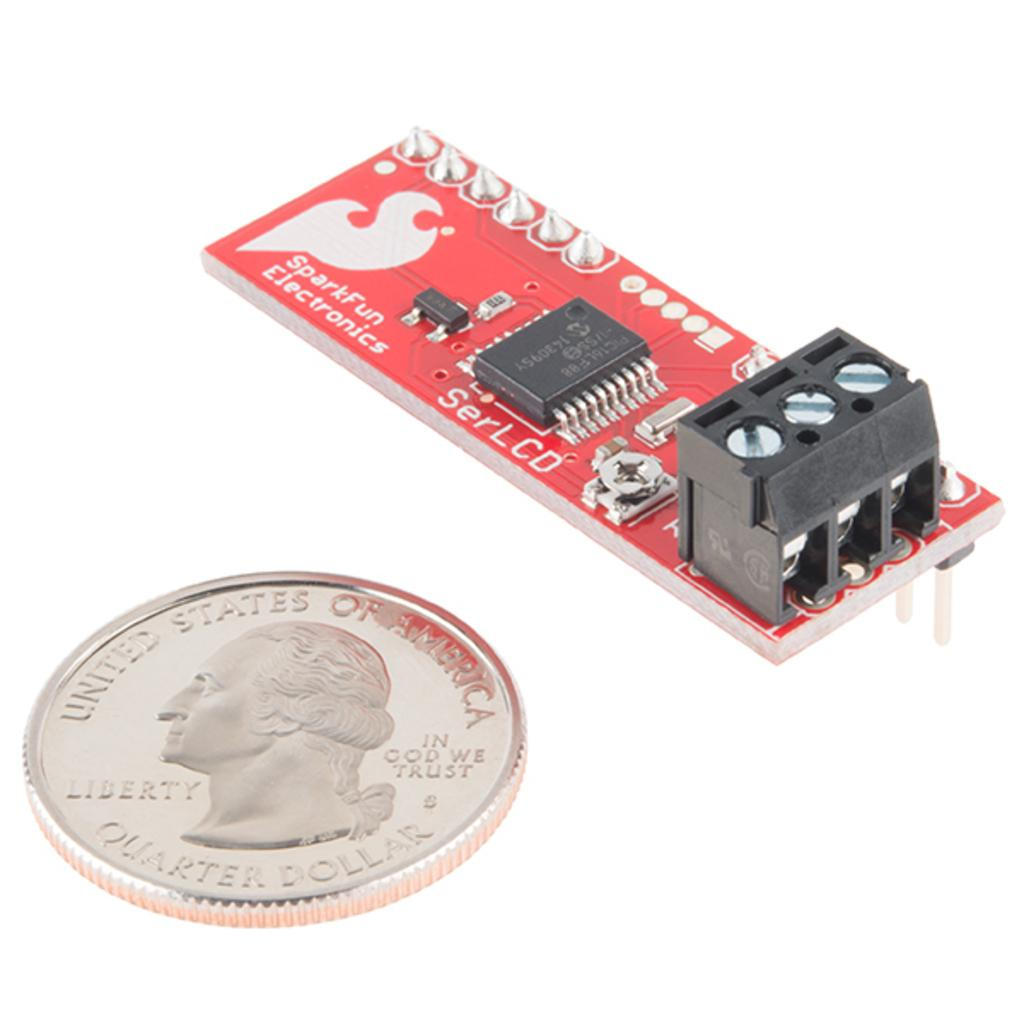<image>
Summarize the visual content of the image. An electronic device that says SparkFun Electronics next to a quarter. 